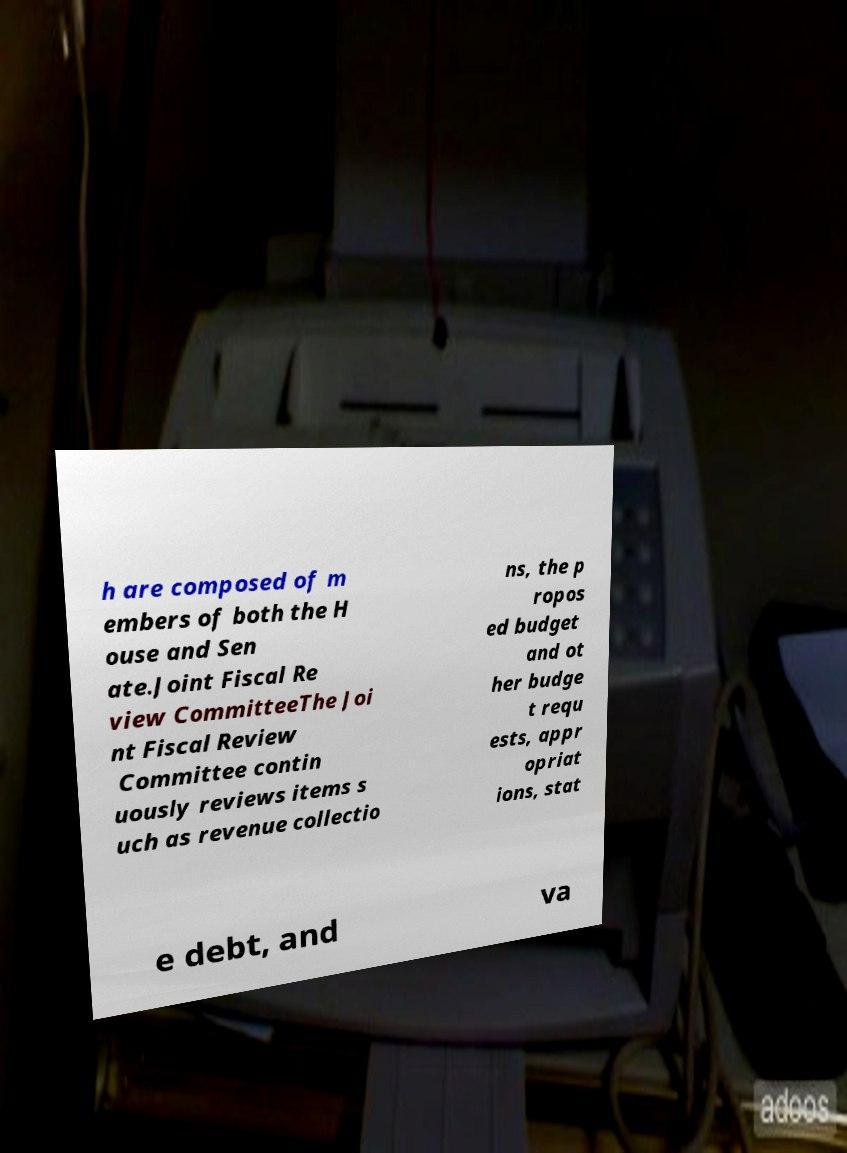Can you accurately transcribe the text from the provided image for me? h are composed of m embers of both the H ouse and Sen ate.Joint Fiscal Re view CommitteeThe Joi nt Fiscal Review Committee contin uously reviews items s uch as revenue collectio ns, the p ropos ed budget and ot her budge t requ ests, appr opriat ions, stat e debt, and va 